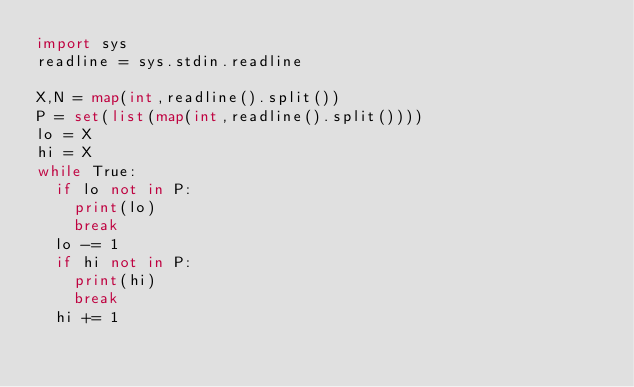Convert code to text. <code><loc_0><loc_0><loc_500><loc_500><_Python_>import sys
readline = sys.stdin.readline

X,N = map(int,readline().split())
P = set(list(map(int,readline().split())))
lo = X
hi = X
while True:
  if lo not in P:
    print(lo)
    break
  lo -= 1
  if hi not in P:
    print(hi)
    break
  hi += 1</code> 